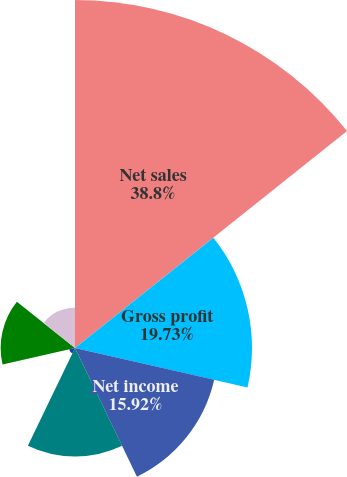Convert chart to OTSL. <chart><loc_0><loc_0><loc_500><loc_500><pie_chart><fcel>Net sales<fcel>Gross profit<fcel>Net income<fcel>Corning's equity in earnings<fcel>Corning transfers of assets at<fcel>Dividends received from<fcel>Royalty income from affiliated<nl><fcel>38.8%<fcel>19.73%<fcel>15.92%<fcel>12.11%<fcel>0.67%<fcel>8.29%<fcel>4.48%<nl></chart> 